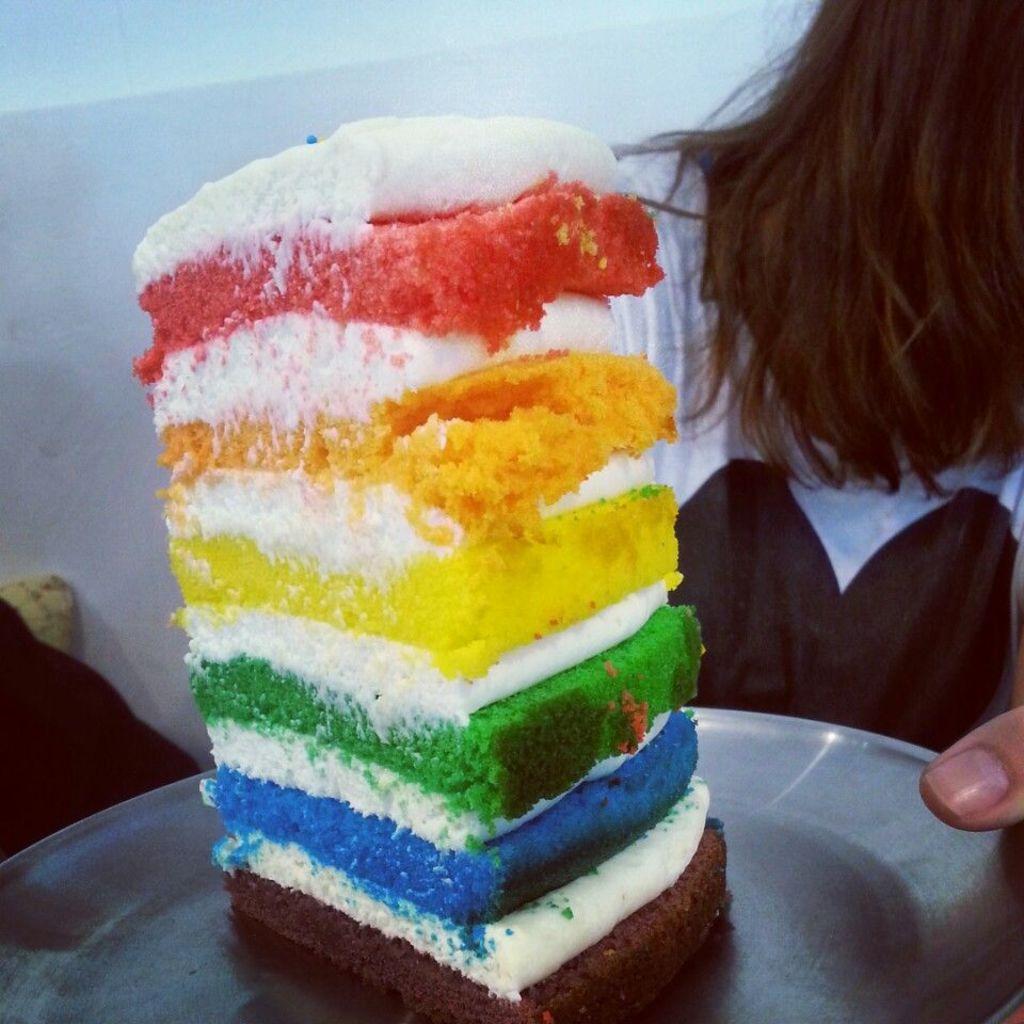Could you give a brief overview of what you see in this image? In this image we can see a person holding a plate containing a piece of cake with cream on it. On the backside we can see a wall. 